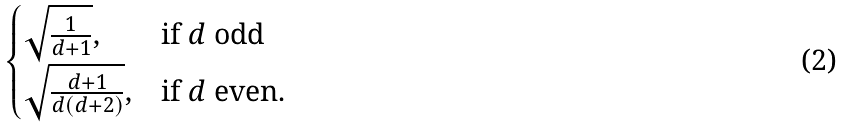Convert formula to latex. <formula><loc_0><loc_0><loc_500><loc_500>\begin{cases} \sqrt { \frac { 1 } { d + 1 } } , & \text {if } d \text { odd} \\ \sqrt { \frac { d + 1 } { d ( d + 2 ) } } , & \text {if } d \text { even.} \end{cases}</formula> 